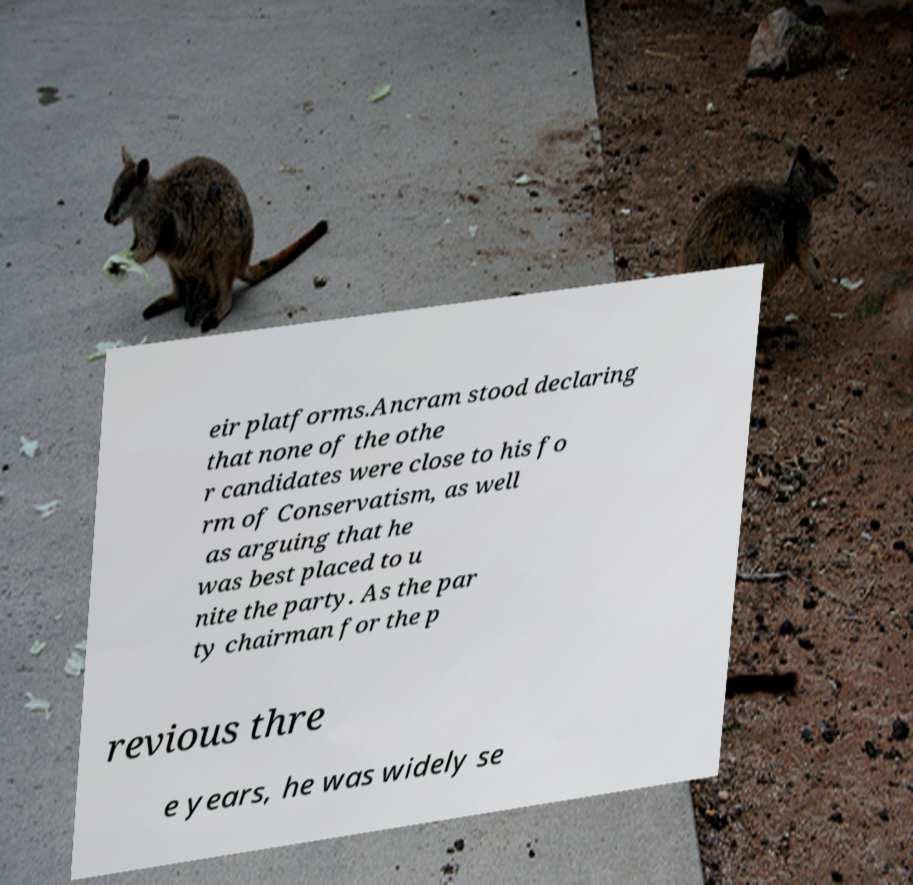Could you assist in decoding the text presented in this image and type it out clearly? eir platforms.Ancram stood declaring that none of the othe r candidates were close to his fo rm of Conservatism, as well as arguing that he was best placed to u nite the party. As the par ty chairman for the p revious thre e years, he was widely se 